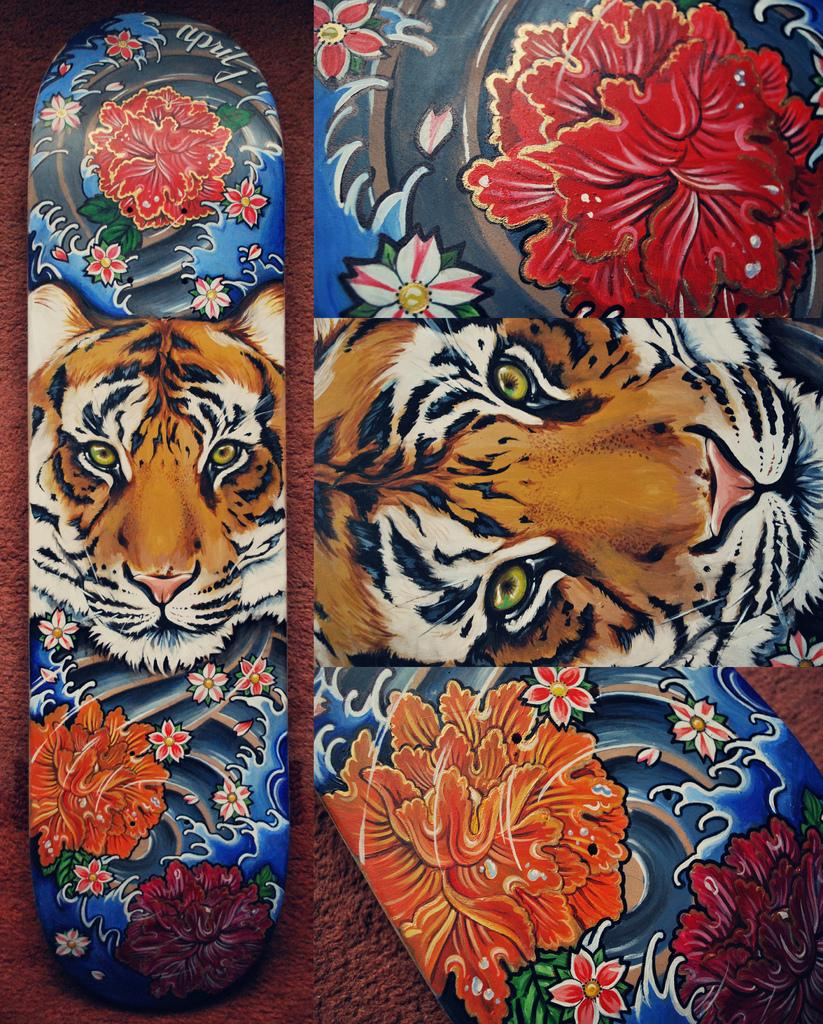What objects are present in the image? There are skateboards in the image. Can you describe the design on the skateboards? The skateboards have floral designs and a tiger design. Where is the jail located in the image? There is no jail present in the image. Can you see any toads or frogs on the skateboards? There are no toads or frogs present in the image. 